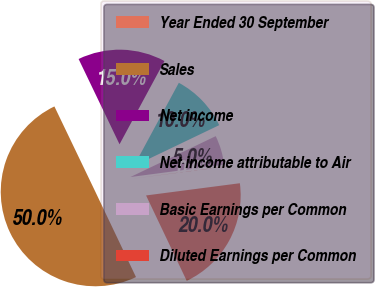Convert chart. <chart><loc_0><loc_0><loc_500><loc_500><pie_chart><fcel>Year Ended 30 September<fcel>Sales<fcel>Net income<fcel>Net income attributable to Air<fcel>Basic Earnings per Common<fcel>Diluted Earnings per Common<nl><fcel>19.99%<fcel>49.95%<fcel>15.0%<fcel>10.01%<fcel>5.02%<fcel>0.03%<nl></chart> 